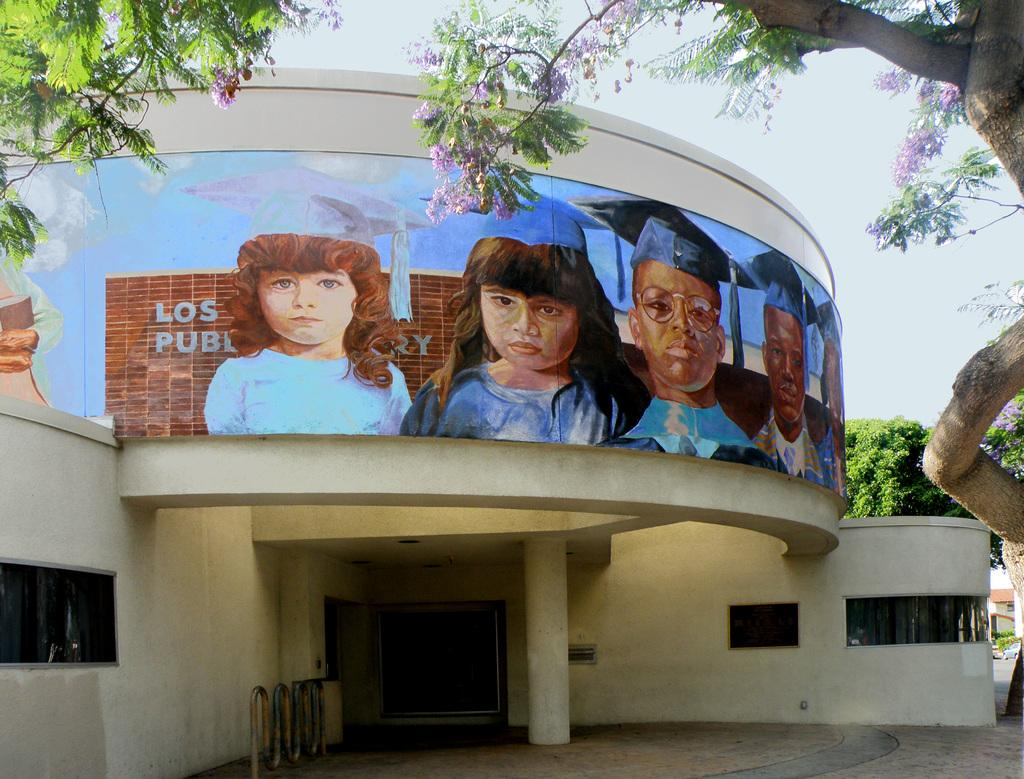What is the main structure visible in the image? There is a building in the image. What can be seen on the building? There are paintings of children on the building. What type of vegetation is on the right side of the image? There is a tall tree with purple flowers on the right side of the image. What color is the yarn used to create the paintings of children on the building? There is no yarn mentioned in the image, and the paintings of children are not described as being created with yarn. 